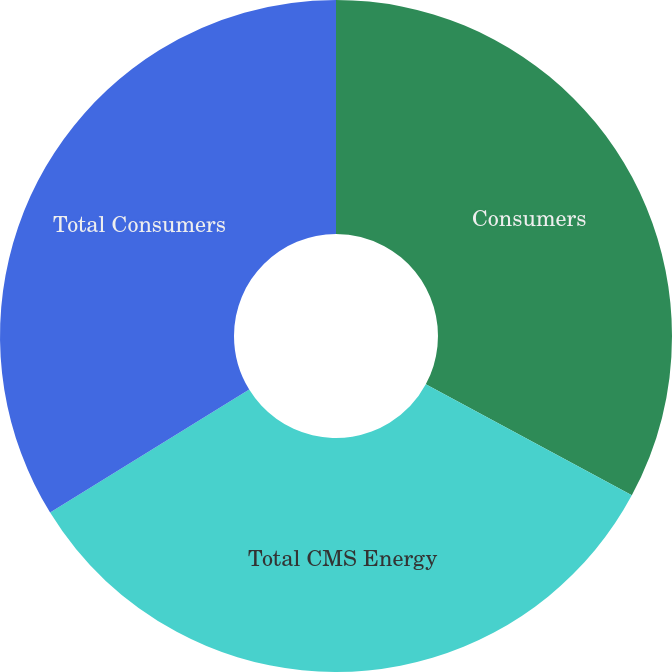Convert chart. <chart><loc_0><loc_0><loc_500><loc_500><pie_chart><fcel>Consumers<fcel>Total CMS Energy<fcel>Total Consumers<nl><fcel>32.86%<fcel>33.33%<fcel>33.8%<nl></chart> 